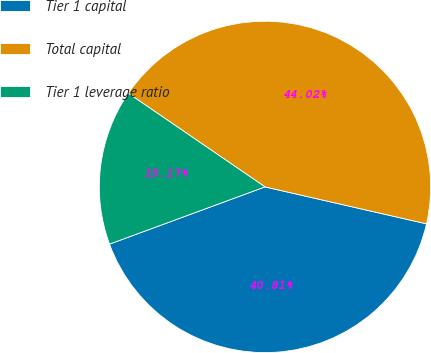Convert chart to OTSL. <chart><loc_0><loc_0><loc_500><loc_500><pie_chart><fcel>Tier 1 capital<fcel>Total capital<fcel>Tier 1 leverage ratio<nl><fcel>40.81%<fcel>44.02%<fcel>15.17%<nl></chart> 